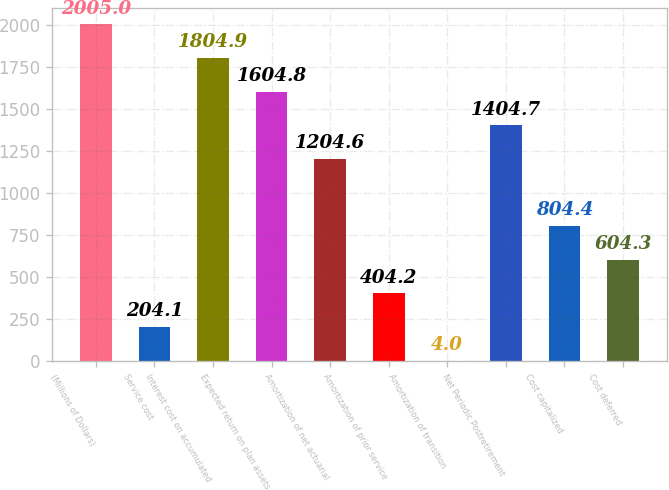Convert chart to OTSL. <chart><loc_0><loc_0><loc_500><loc_500><bar_chart><fcel>(Millions of Dollars)<fcel>Service cost<fcel>Interest cost on accumulated<fcel>Expected return on plan assets<fcel>Amortization of net actuarial<fcel>Amortization of prior service<fcel>Amortization of transition<fcel>Net Periodic Postretirement<fcel>Cost capitalized<fcel>Cost deferred<nl><fcel>2005<fcel>204.1<fcel>1804.9<fcel>1604.8<fcel>1204.6<fcel>404.2<fcel>4<fcel>1404.7<fcel>804.4<fcel>604.3<nl></chart> 